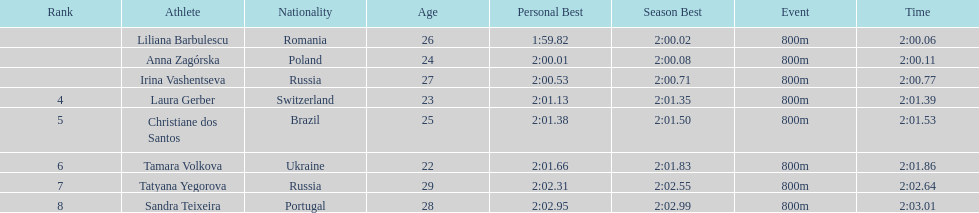How many runners finished with their time below 2:01? 3. 